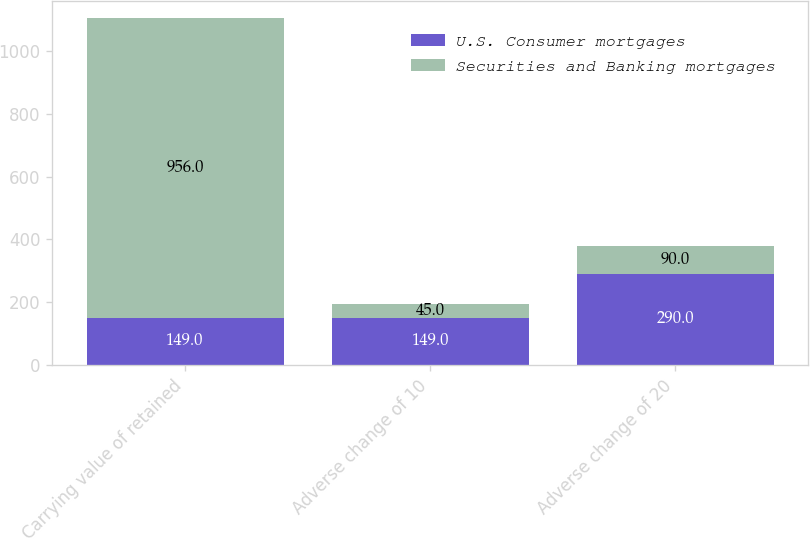<chart> <loc_0><loc_0><loc_500><loc_500><stacked_bar_chart><ecel><fcel>Carrying value of retained<fcel>Adverse change of 10<fcel>Adverse change of 20<nl><fcel>U.S. Consumer mortgages<fcel>149<fcel>149<fcel>290<nl><fcel>Securities and Banking mortgages<fcel>956<fcel>45<fcel>90<nl></chart> 